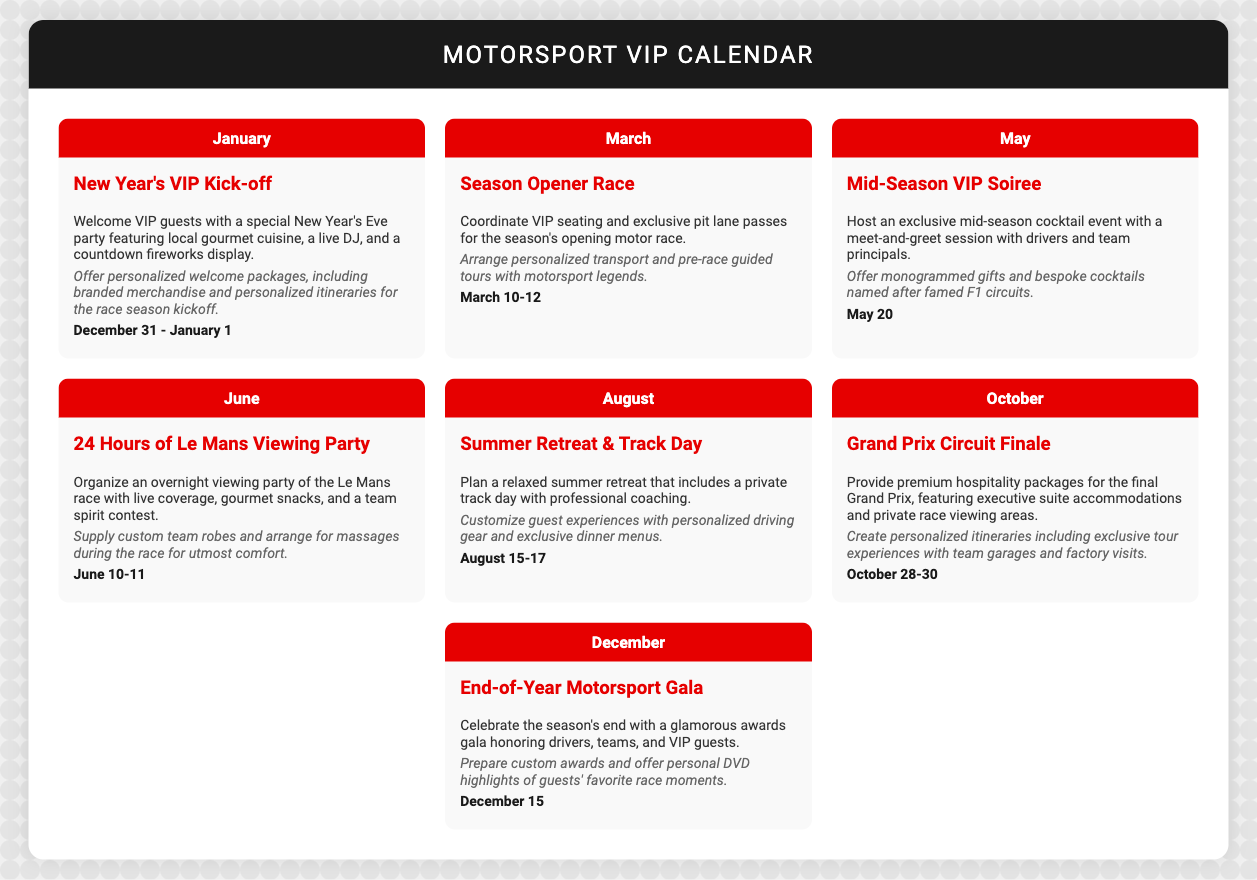What event kicks off the New Year? The event specifically mentioned for the New Year's kick-off is a special New Year's Eve party.
Answer: New Year's VIP Kick-off What month is the Grand Prix Circuit Finale scheduled for? The month highlighted for the Grand Prix Circuit Finale is October.
Answer: October How long does the 24 Hours of Le Mans Viewing Party last? The duration of the 24 Hours of Le Mans Viewing Party is specified as June 10-11.
Answer: June 10-11 What type of event is the Mid-Season VIP Soiree? The Mid-Season VIP Soiree is a cocktail event with a meet-and-greet.
Answer: Cocktail event What personalized service is offered during the Summer Retreat & Track Day? The document mentions customizing guest experiences with personalized driving gear.
Answer: Personalized driving gear What unique item is prepared for the End-of-Year Motorsport Gala? The document states that custom awards are prepared for the End-of-Year Motorsport Gala.
Answer: Custom awards What is featured during the Season Opener Race? The key features of the Season Opener Race include VIP seating and exclusive pit lane passes.
Answer: VIP seating and exclusive pit lane passes What is the date for the Mid-Season VIP Soiree? The specific date given for this event is May 20.
Answer: May 20 What is unique about the personalization for the New Year's VIP Kick-off? The New Year's VIP Kick-off includes personalized welcome packages as part of its unique offerings.
Answer: Personalized welcome packages 